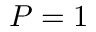<formula> <loc_0><loc_0><loc_500><loc_500>P = 1</formula> 